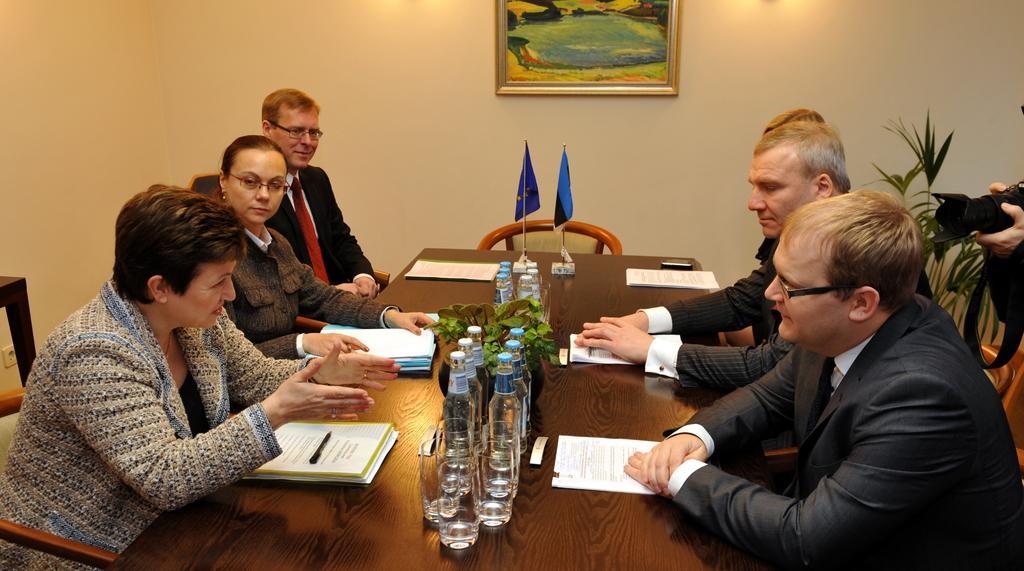Please provide a concise description of this image. In this picture we can see a group of people sitting in a board room in which a lady is explaining something and having files and papers in front of her. Another woman is sitting beside her and listening to her and man beside wearing a red tie and black coat is smiling. And There is Big Cream color wall with painting on it. We a have two small flags and water bottle on the table. On The right side three persons are sitting and listening to her and a camera man shooting this Woman. 